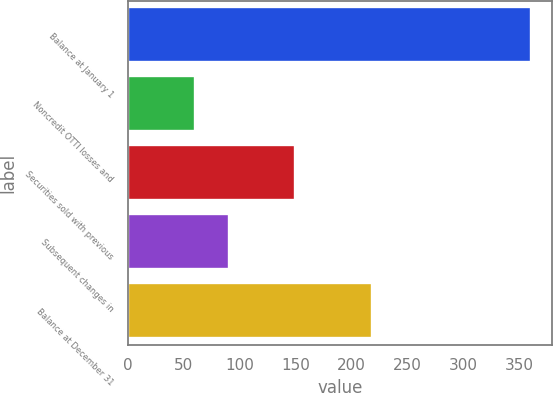Convert chart. <chart><loc_0><loc_0><loc_500><loc_500><bar_chart><fcel>Balance at January 1<fcel>Noncredit OTTI losses and<fcel>Securities sold with previous<fcel>Subsequent changes in<fcel>Balance at December 31<nl><fcel>361<fcel>60<fcel>149<fcel>90.1<fcel>218<nl></chart> 